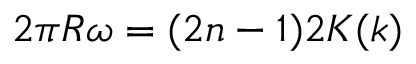<formula> <loc_0><loc_0><loc_500><loc_500>2 \pi R \omega = ( 2 n - 1 ) 2 K ( k )</formula> 